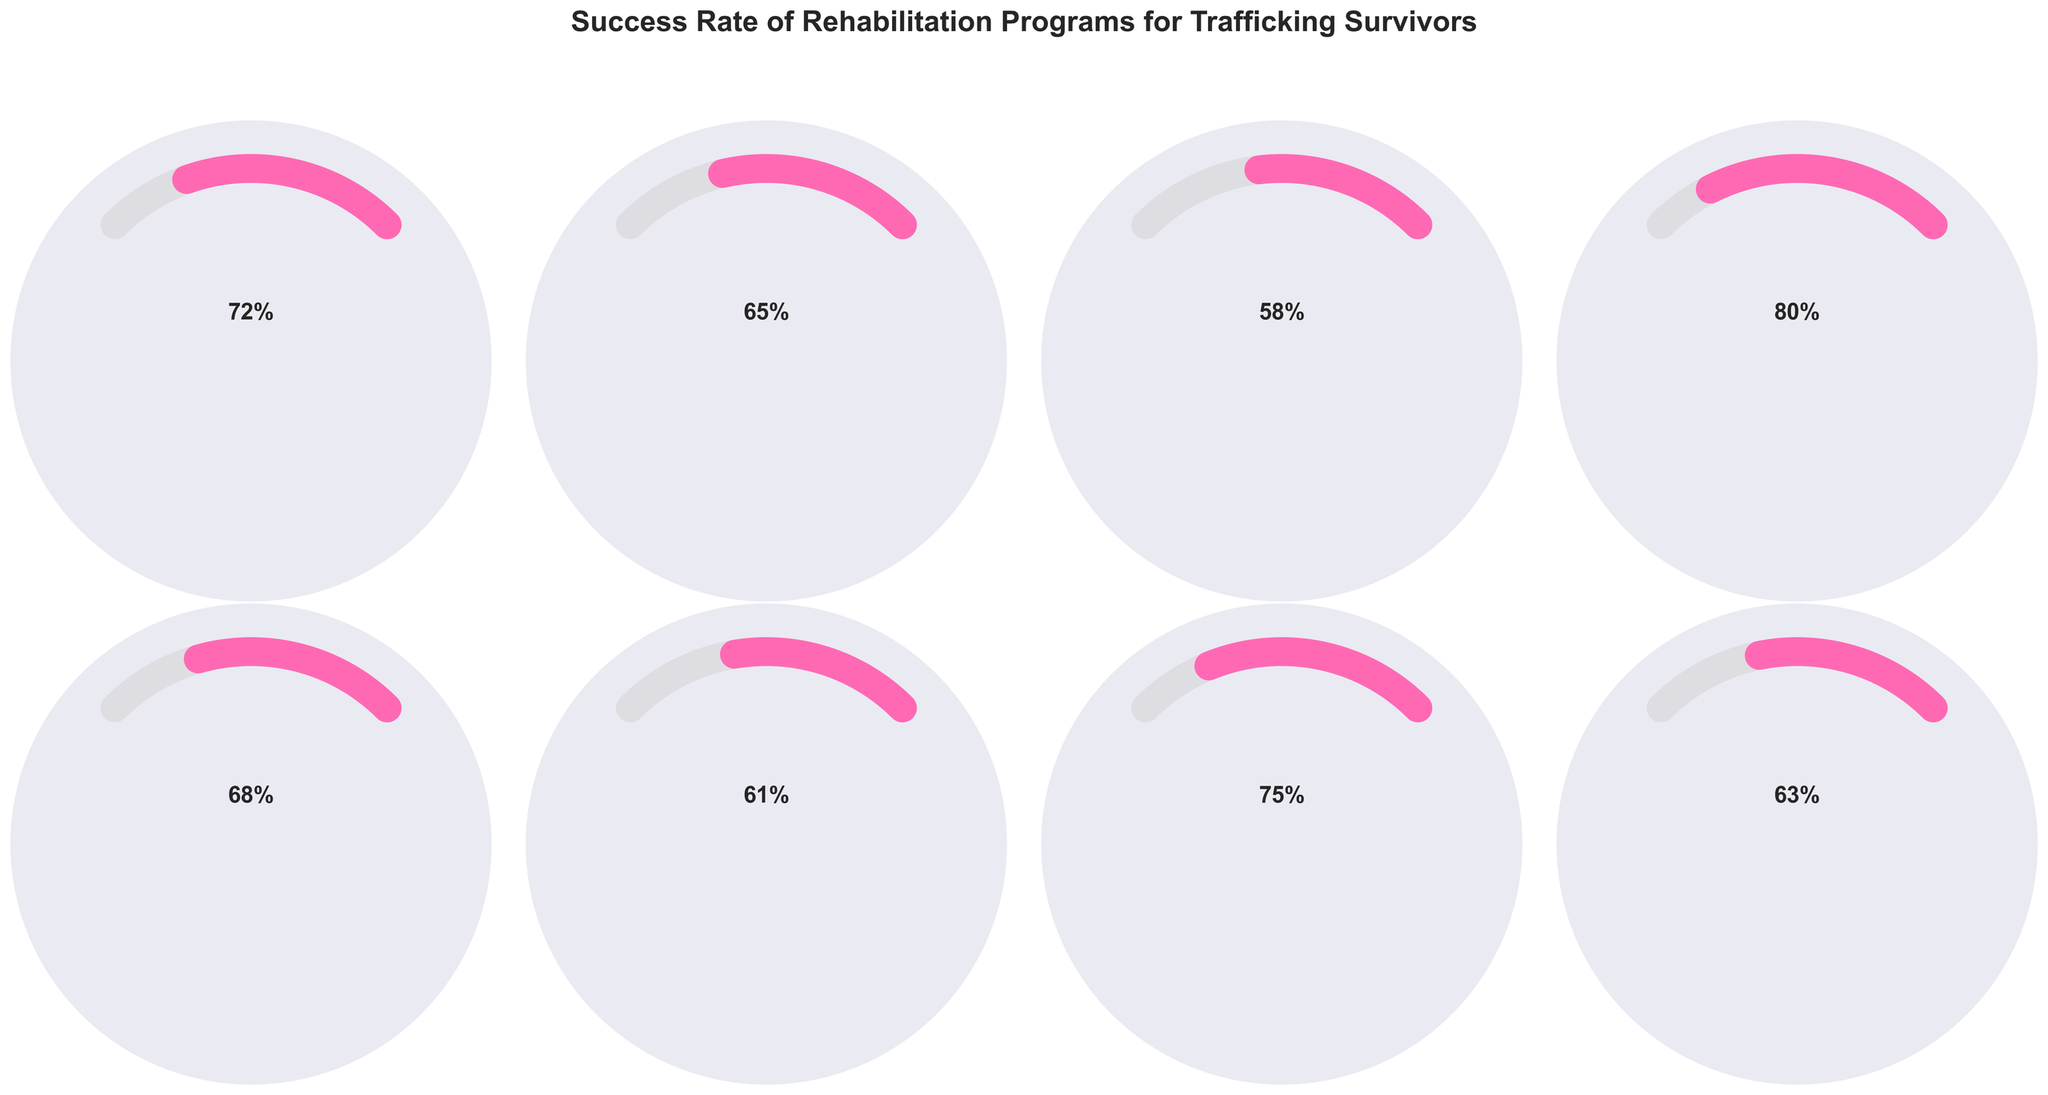What is the success rate of the "Border Light" program? The "Border Light" program in San Diego is represented by one of the gauges in the figure. The radial position and the value text indicate the success rate.
Answer: 80% Which program has the lowest success rate? By comparing the values displayed on each gauge, "Renacimiento" is seen to have the lowest success rate at 58%.
Answer: Renacimiento What is the difference in success rates between "Mujeres Unidas" and "Camino a la Libertad"? "Mujeres Unidas" has a success rate of 68%, while "Camino a la Libertad" has a success rate of 61%. The difference is calculated as 68% - 61%.
Answer: 7% Calculate the average success rate of all the programs. Sum the success rates of all programs and divide by the number of programs. (72 + 65 + 58 + 80 + 68 + 61 + 75 + 63) / 8 = 67.75
Answer: 67.75% How many programs have a success rate above 70%? Count the number of programs with success rates higher than 70%. "Nuevo Amanecer", "Border Light", and "Vida Nueva" have success rates above 70%.
Answer: 3 Which program has a higher success rate: "Hope Recovery Center" or "Esperanza Project"? Compare the success rates of "Hope Recovery Center" (65%) and "Esperanza Project" (63%).
Answer: Hope Recovery Center What is the median success rate of the programs? Arrange the success rates in ascending order: 58, 61, 63, 65, 68, 72, 75, 80. The median is the average of the 4th and 5th values: (65 + 68) / 2.
Answer: 66.5% What is the success rate of the "Vida Nueva" program? The "Vida Nueva" program in Brownsville is represented by one of the gauges in the figure. The radial position and the value text indicate the success rate.
Answer: 75% What's the range of success rates across the programs? The range is calculated by subtracting the lowest success rate from the highest success rate: 80% - 58%.
Answer: 22% How many programs have a success rate below 65%? Count the programs with success rates under 65%. "Renacimiento", "Camino a la Libertad", and "Esperanza Project" have success rates below 65%.
Answer: 3 